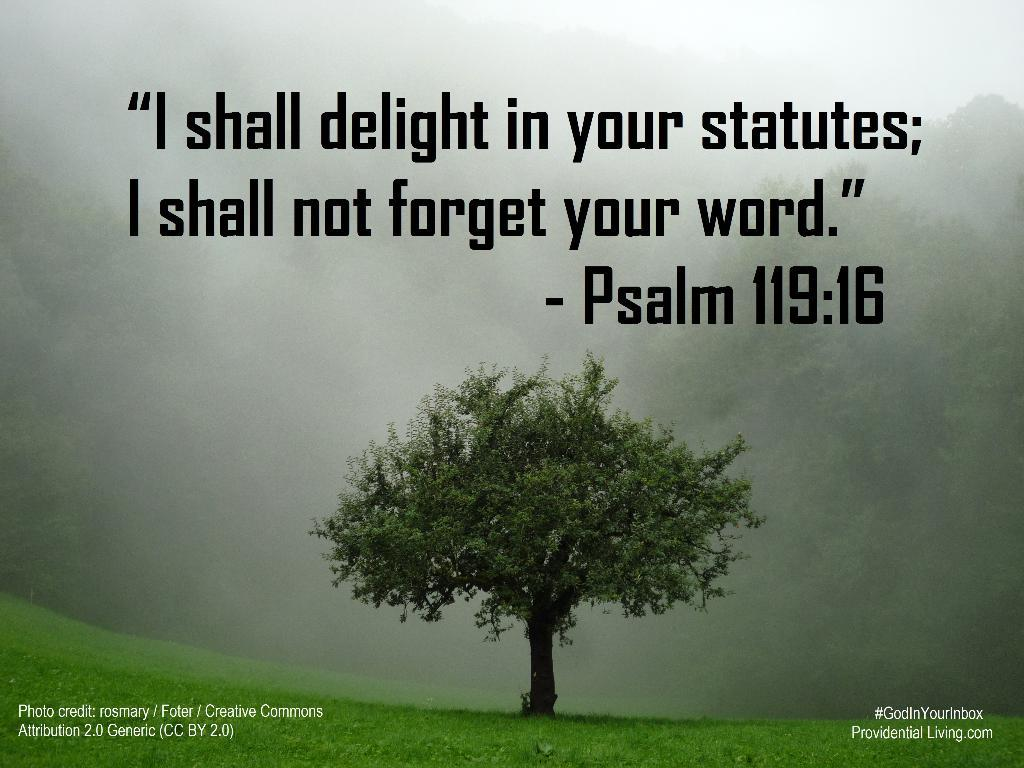What type of visual is the image? The image is a poster. What is depicted at the bottom of the poster? There is a ground with grass at the bottom of the image. What can be found at the top of the poster? There is a quote at the top of the image. What is located in the middle of the poster? There is a tree in the middle of the image. Can you see a goat grazing on the grass in the image? There is no goat present in the image; it only features a ground with grass, a quote, and a tree. How many hands are visible in the image? There are no hands visible in the image. 